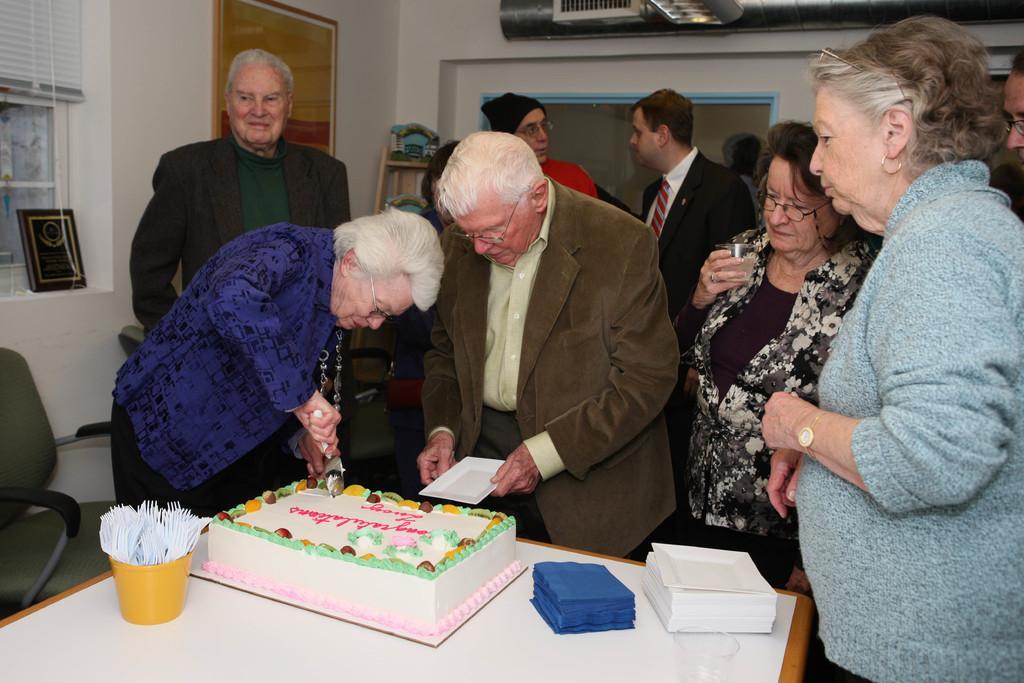How would you summarize this image in a sentence or two? In this image I can see a group of people standing. In front there is a cake,fork and a tissues on the table. There are chairs. In front the woman is cutting the cake. At the back side there is white wall and a frame. 